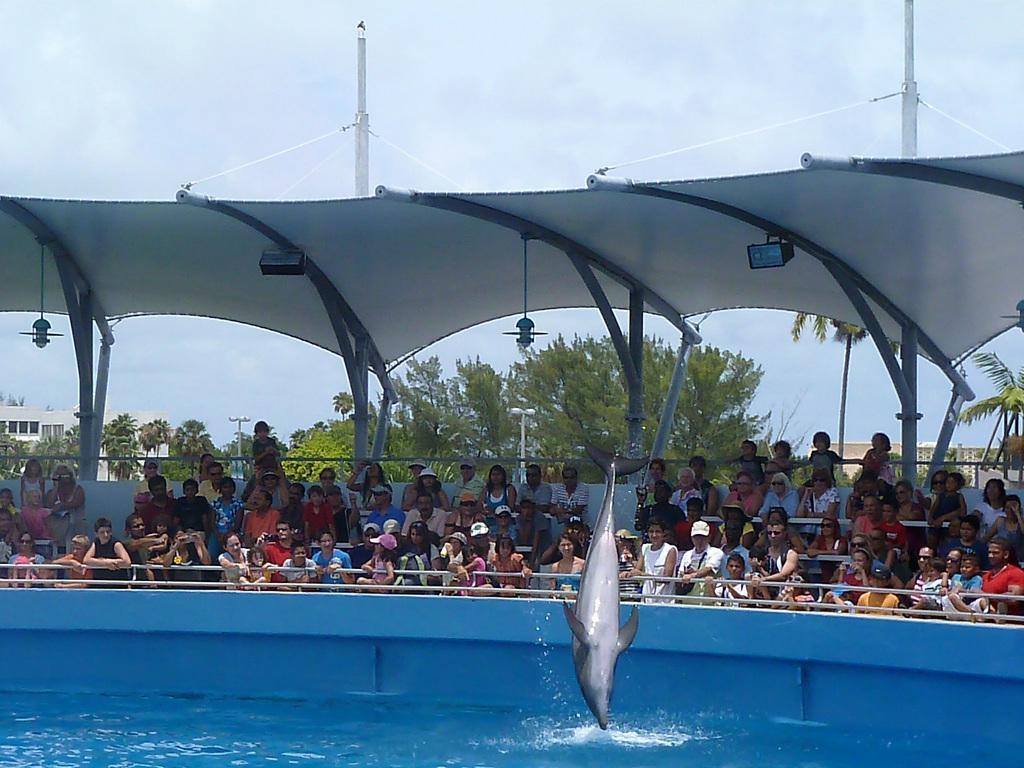Describe this image in one or two sentences. In this image we can see a dolphin on the water. In the background ,we can see group of people sitting on chairs under a shed with some lights and poles ,group of trees ,building and sky. 